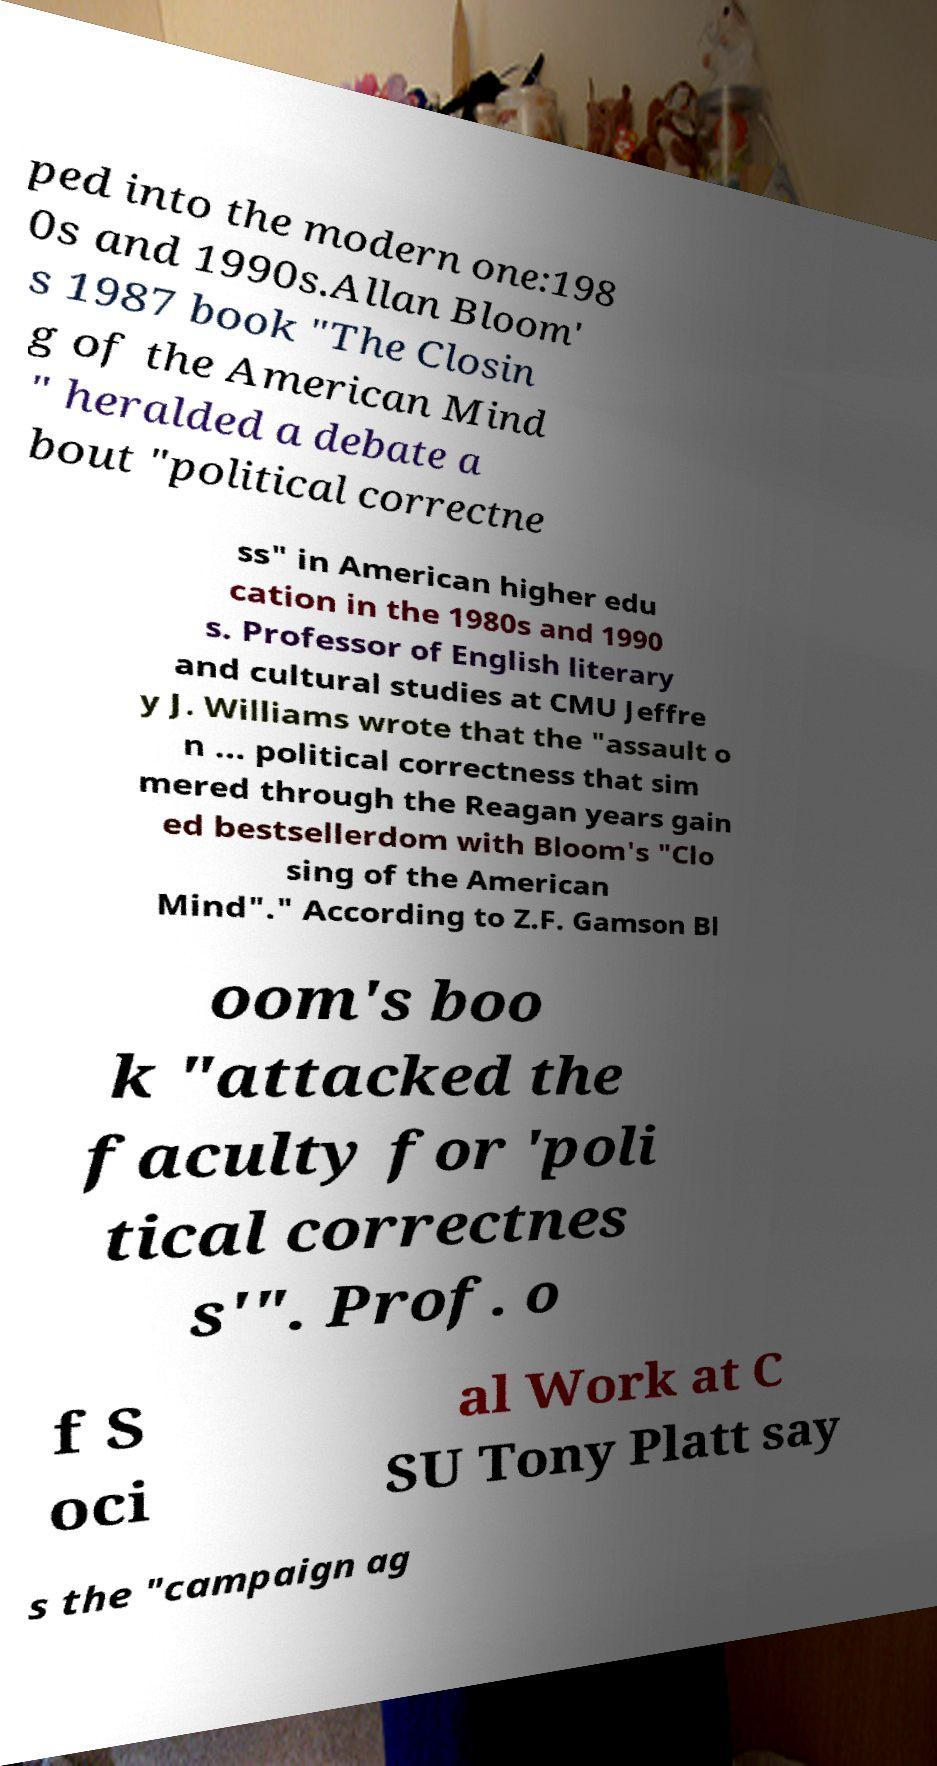Please read and relay the text visible in this image. What does it say? ped into the modern one:198 0s and 1990s.Allan Bloom' s 1987 book "The Closin g of the American Mind " heralded a debate a bout "political correctne ss" in American higher edu cation in the 1980s and 1990 s. Professor of English literary and cultural studies at CMU Jeffre y J. Williams wrote that the "assault o n ... political correctness that sim mered through the Reagan years gain ed bestsellerdom with Bloom's "Clo sing of the American Mind"." According to Z.F. Gamson Bl oom's boo k "attacked the faculty for 'poli tical correctnes s'". Prof. o f S oci al Work at C SU Tony Platt say s the "campaign ag 